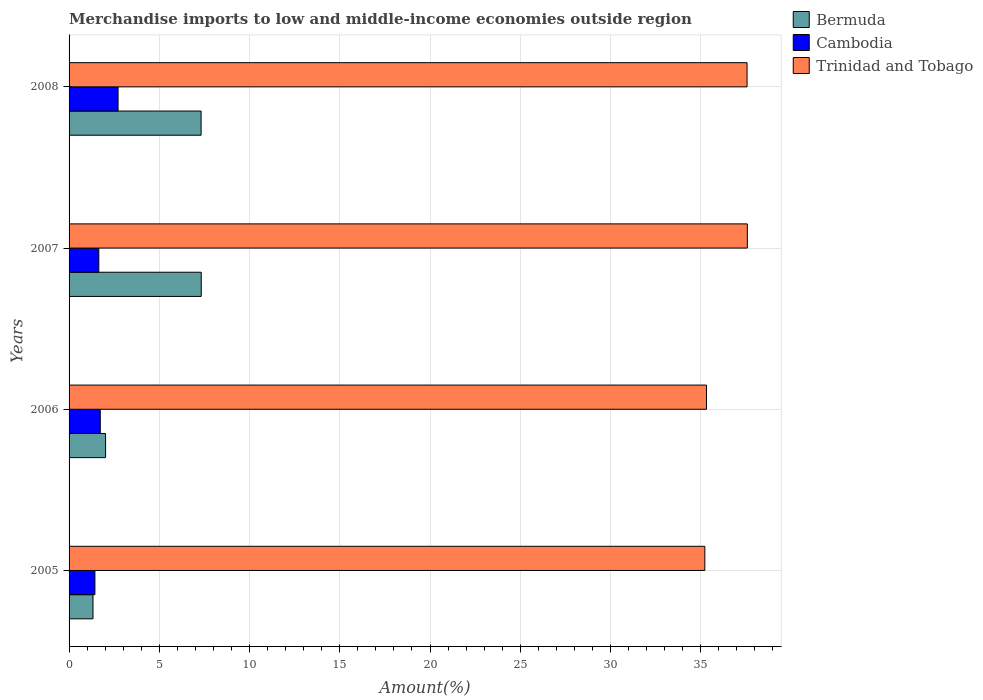How many different coloured bars are there?
Give a very brief answer. 3. Are the number of bars per tick equal to the number of legend labels?
Give a very brief answer. Yes. Are the number of bars on each tick of the Y-axis equal?
Your answer should be compact. Yes. What is the label of the 3rd group of bars from the top?
Keep it short and to the point. 2006. In how many cases, is the number of bars for a given year not equal to the number of legend labels?
Make the answer very short. 0. What is the percentage of amount earned from merchandise imports in Bermuda in 2007?
Your answer should be very brief. 7.32. Across all years, what is the maximum percentage of amount earned from merchandise imports in Bermuda?
Make the answer very short. 7.32. Across all years, what is the minimum percentage of amount earned from merchandise imports in Cambodia?
Offer a very short reply. 1.43. In which year was the percentage of amount earned from merchandise imports in Trinidad and Tobago maximum?
Give a very brief answer. 2007. What is the total percentage of amount earned from merchandise imports in Trinidad and Tobago in the graph?
Give a very brief answer. 145.7. What is the difference between the percentage of amount earned from merchandise imports in Bermuda in 2005 and that in 2007?
Give a very brief answer. -6. What is the difference between the percentage of amount earned from merchandise imports in Cambodia in 2006 and the percentage of amount earned from merchandise imports in Bermuda in 2005?
Offer a terse response. 0.4. What is the average percentage of amount earned from merchandise imports in Cambodia per year?
Offer a very short reply. 1.88. In the year 2005, what is the difference between the percentage of amount earned from merchandise imports in Bermuda and percentage of amount earned from merchandise imports in Cambodia?
Make the answer very short. -0.11. In how many years, is the percentage of amount earned from merchandise imports in Cambodia greater than 33 %?
Provide a succinct answer. 0. What is the ratio of the percentage of amount earned from merchandise imports in Bermuda in 2005 to that in 2008?
Give a very brief answer. 0.18. Is the percentage of amount earned from merchandise imports in Trinidad and Tobago in 2005 less than that in 2006?
Keep it short and to the point. Yes. What is the difference between the highest and the second highest percentage of amount earned from merchandise imports in Bermuda?
Ensure brevity in your answer.  0.01. What is the difference between the highest and the lowest percentage of amount earned from merchandise imports in Trinidad and Tobago?
Offer a terse response. 2.35. Is the sum of the percentage of amount earned from merchandise imports in Trinidad and Tobago in 2005 and 2006 greater than the maximum percentage of amount earned from merchandise imports in Bermuda across all years?
Make the answer very short. Yes. What does the 3rd bar from the top in 2007 represents?
Provide a short and direct response. Bermuda. What does the 2nd bar from the bottom in 2007 represents?
Your response must be concise. Cambodia. Is it the case that in every year, the sum of the percentage of amount earned from merchandise imports in Cambodia and percentage of amount earned from merchandise imports in Bermuda is greater than the percentage of amount earned from merchandise imports in Trinidad and Tobago?
Keep it short and to the point. No. How many bars are there?
Your response must be concise. 12. Are all the bars in the graph horizontal?
Provide a short and direct response. Yes. How many years are there in the graph?
Offer a terse response. 4. Are the values on the major ticks of X-axis written in scientific E-notation?
Your answer should be very brief. No. Does the graph contain grids?
Make the answer very short. Yes. What is the title of the graph?
Ensure brevity in your answer.  Merchandise imports to low and middle-income economies outside region. What is the label or title of the X-axis?
Your response must be concise. Amount(%). What is the label or title of the Y-axis?
Offer a very short reply. Years. What is the Amount(%) in Bermuda in 2005?
Keep it short and to the point. 1.33. What is the Amount(%) of Cambodia in 2005?
Offer a very short reply. 1.43. What is the Amount(%) of Trinidad and Tobago in 2005?
Your answer should be very brief. 35.23. What is the Amount(%) of Bermuda in 2006?
Provide a succinct answer. 2.02. What is the Amount(%) of Cambodia in 2006?
Offer a very short reply. 1.73. What is the Amount(%) in Trinidad and Tobago in 2006?
Ensure brevity in your answer.  35.32. What is the Amount(%) in Bermuda in 2007?
Keep it short and to the point. 7.32. What is the Amount(%) in Cambodia in 2007?
Keep it short and to the point. 1.65. What is the Amount(%) in Trinidad and Tobago in 2007?
Your response must be concise. 37.58. What is the Amount(%) of Bermuda in 2008?
Your answer should be compact. 7.32. What is the Amount(%) of Cambodia in 2008?
Make the answer very short. 2.71. What is the Amount(%) in Trinidad and Tobago in 2008?
Your answer should be very brief. 37.57. Across all years, what is the maximum Amount(%) in Bermuda?
Your answer should be very brief. 7.32. Across all years, what is the maximum Amount(%) in Cambodia?
Offer a very short reply. 2.71. Across all years, what is the maximum Amount(%) in Trinidad and Tobago?
Your answer should be very brief. 37.58. Across all years, what is the minimum Amount(%) of Bermuda?
Ensure brevity in your answer.  1.33. Across all years, what is the minimum Amount(%) in Cambodia?
Your answer should be compact. 1.43. Across all years, what is the minimum Amount(%) of Trinidad and Tobago?
Your answer should be very brief. 35.23. What is the total Amount(%) of Bermuda in the graph?
Provide a short and direct response. 17.99. What is the total Amount(%) of Cambodia in the graph?
Your answer should be compact. 7.52. What is the total Amount(%) of Trinidad and Tobago in the graph?
Ensure brevity in your answer.  145.7. What is the difference between the Amount(%) of Bermuda in 2005 and that in 2006?
Offer a terse response. -0.7. What is the difference between the Amount(%) in Cambodia in 2005 and that in 2006?
Your response must be concise. -0.3. What is the difference between the Amount(%) of Trinidad and Tobago in 2005 and that in 2006?
Provide a succinct answer. -0.09. What is the difference between the Amount(%) of Bermuda in 2005 and that in 2007?
Your response must be concise. -6. What is the difference between the Amount(%) in Cambodia in 2005 and that in 2007?
Ensure brevity in your answer.  -0.22. What is the difference between the Amount(%) in Trinidad and Tobago in 2005 and that in 2007?
Make the answer very short. -2.35. What is the difference between the Amount(%) of Bermuda in 2005 and that in 2008?
Your answer should be compact. -5.99. What is the difference between the Amount(%) of Cambodia in 2005 and that in 2008?
Provide a succinct answer. -1.28. What is the difference between the Amount(%) in Trinidad and Tobago in 2005 and that in 2008?
Give a very brief answer. -2.34. What is the difference between the Amount(%) of Bermuda in 2006 and that in 2007?
Offer a terse response. -5.3. What is the difference between the Amount(%) of Cambodia in 2006 and that in 2007?
Your answer should be compact. 0.08. What is the difference between the Amount(%) of Trinidad and Tobago in 2006 and that in 2007?
Ensure brevity in your answer.  -2.26. What is the difference between the Amount(%) of Bermuda in 2006 and that in 2008?
Keep it short and to the point. -5.29. What is the difference between the Amount(%) in Cambodia in 2006 and that in 2008?
Provide a succinct answer. -0.99. What is the difference between the Amount(%) in Trinidad and Tobago in 2006 and that in 2008?
Your answer should be very brief. -2.25. What is the difference between the Amount(%) of Bermuda in 2007 and that in 2008?
Keep it short and to the point. 0.01. What is the difference between the Amount(%) in Cambodia in 2007 and that in 2008?
Ensure brevity in your answer.  -1.07. What is the difference between the Amount(%) in Trinidad and Tobago in 2007 and that in 2008?
Keep it short and to the point. 0.01. What is the difference between the Amount(%) in Bermuda in 2005 and the Amount(%) in Cambodia in 2006?
Your answer should be very brief. -0.4. What is the difference between the Amount(%) in Bermuda in 2005 and the Amount(%) in Trinidad and Tobago in 2006?
Provide a succinct answer. -33.99. What is the difference between the Amount(%) of Cambodia in 2005 and the Amount(%) of Trinidad and Tobago in 2006?
Offer a very short reply. -33.89. What is the difference between the Amount(%) in Bermuda in 2005 and the Amount(%) in Cambodia in 2007?
Ensure brevity in your answer.  -0.32. What is the difference between the Amount(%) of Bermuda in 2005 and the Amount(%) of Trinidad and Tobago in 2007?
Provide a short and direct response. -36.26. What is the difference between the Amount(%) of Cambodia in 2005 and the Amount(%) of Trinidad and Tobago in 2007?
Keep it short and to the point. -36.15. What is the difference between the Amount(%) in Bermuda in 2005 and the Amount(%) in Cambodia in 2008?
Your response must be concise. -1.39. What is the difference between the Amount(%) of Bermuda in 2005 and the Amount(%) of Trinidad and Tobago in 2008?
Your answer should be compact. -36.24. What is the difference between the Amount(%) in Cambodia in 2005 and the Amount(%) in Trinidad and Tobago in 2008?
Your answer should be very brief. -36.14. What is the difference between the Amount(%) of Bermuda in 2006 and the Amount(%) of Cambodia in 2007?
Offer a terse response. 0.37. What is the difference between the Amount(%) in Bermuda in 2006 and the Amount(%) in Trinidad and Tobago in 2007?
Offer a terse response. -35.56. What is the difference between the Amount(%) in Cambodia in 2006 and the Amount(%) in Trinidad and Tobago in 2007?
Your response must be concise. -35.85. What is the difference between the Amount(%) in Bermuda in 2006 and the Amount(%) in Cambodia in 2008?
Offer a terse response. -0.69. What is the difference between the Amount(%) in Bermuda in 2006 and the Amount(%) in Trinidad and Tobago in 2008?
Ensure brevity in your answer.  -35.55. What is the difference between the Amount(%) in Cambodia in 2006 and the Amount(%) in Trinidad and Tobago in 2008?
Give a very brief answer. -35.84. What is the difference between the Amount(%) of Bermuda in 2007 and the Amount(%) of Cambodia in 2008?
Offer a terse response. 4.61. What is the difference between the Amount(%) of Bermuda in 2007 and the Amount(%) of Trinidad and Tobago in 2008?
Offer a very short reply. -30.24. What is the difference between the Amount(%) in Cambodia in 2007 and the Amount(%) in Trinidad and Tobago in 2008?
Provide a succinct answer. -35.92. What is the average Amount(%) in Bermuda per year?
Your response must be concise. 4.5. What is the average Amount(%) of Cambodia per year?
Provide a short and direct response. 1.88. What is the average Amount(%) in Trinidad and Tobago per year?
Give a very brief answer. 36.42. In the year 2005, what is the difference between the Amount(%) of Bermuda and Amount(%) of Cambodia?
Provide a short and direct response. -0.11. In the year 2005, what is the difference between the Amount(%) of Bermuda and Amount(%) of Trinidad and Tobago?
Give a very brief answer. -33.9. In the year 2005, what is the difference between the Amount(%) of Cambodia and Amount(%) of Trinidad and Tobago?
Your response must be concise. -33.8. In the year 2006, what is the difference between the Amount(%) of Bermuda and Amount(%) of Cambodia?
Provide a short and direct response. 0.29. In the year 2006, what is the difference between the Amount(%) in Bermuda and Amount(%) in Trinidad and Tobago?
Your response must be concise. -33.3. In the year 2006, what is the difference between the Amount(%) of Cambodia and Amount(%) of Trinidad and Tobago?
Ensure brevity in your answer.  -33.59. In the year 2007, what is the difference between the Amount(%) of Bermuda and Amount(%) of Cambodia?
Provide a succinct answer. 5.68. In the year 2007, what is the difference between the Amount(%) of Bermuda and Amount(%) of Trinidad and Tobago?
Make the answer very short. -30.26. In the year 2007, what is the difference between the Amount(%) in Cambodia and Amount(%) in Trinidad and Tobago?
Your response must be concise. -35.94. In the year 2008, what is the difference between the Amount(%) of Bermuda and Amount(%) of Cambodia?
Ensure brevity in your answer.  4.6. In the year 2008, what is the difference between the Amount(%) of Bermuda and Amount(%) of Trinidad and Tobago?
Provide a succinct answer. -30.25. In the year 2008, what is the difference between the Amount(%) of Cambodia and Amount(%) of Trinidad and Tobago?
Give a very brief answer. -34.85. What is the ratio of the Amount(%) of Bermuda in 2005 to that in 2006?
Provide a succinct answer. 0.66. What is the ratio of the Amount(%) in Cambodia in 2005 to that in 2006?
Ensure brevity in your answer.  0.83. What is the ratio of the Amount(%) of Trinidad and Tobago in 2005 to that in 2006?
Provide a short and direct response. 1. What is the ratio of the Amount(%) of Bermuda in 2005 to that in 2007?
Your answer should be compact. 0.18. What is the ratio of the Amount(%) of Cambodia in 2005 to that in 2007?
Provide a short and direct response. 0.87. What is the ratio of the Amount(%) of Trinidad and Tobago in 2005 to that in 2007?
Provide a short and direct response. 0.94. What is the ratio of the Amount(%) in Bermuda in 2005 to that in 2008?
Make the answer very short. 0.18. What is the ratio of the Amount(%) in Cambodia in 2005 to that in 2008?
Keep it short and to the point. 0.53. What is the ratio of the Amount(%) of Trinidad and Tobago in 2005 to that in 2008?
Give a very brief answer. 0.94. What is the ratio of the Amount(%) in Bermuda in 2006 to that in 2007?
Provide a short and direct response. 0.28. What is the ratio of the Amount(%) of Cambodia in 2006 to that in 2007?
Give a very brief answer. 1.05. What is the ratio of the Amount(%) of Trinidad and Tobago in 2006 to that in 2007?
Your answer should be compact. 0.94. What is the ratio of the Amount(%) of Bermuda in 2006 to that in 2008?
Keep it short and to the point. 0.28. What is the ratio of the Amount(%) in Cambodia in 2006 to that in 2008?
Keep it short and to the point. 0.64. What is the ratio of the Amount(%) of Trinidad and Tobago in 2006 to that in 2008?
Your response must be concise. 0.94. What is the ratio of the Amount(%) of Cambodia in 2007 to that in 2008?
Offer a very short reply. 0.61. What is the difference between the highest and the second highest Amount(%) in Bermuda?
Your answer should be compact. 0.01. What is the difference between the highest and the second highest Amount(%) in Cambodia?
Your answer should be compact. 0.99. What is the difference between the highest and the second highest Amount(%) in Trinidad and Tobago?
Your answer should be very brief. 0.01. What is the difference between the highest and the lowest Amount(%) of Bermuda?
Offer a very short reply. 6. What is the difference between the highest and the lowest Amount(%) in Cambodia?
Provide a short and direct response. 1.28. What is the difference between the highest and the lowest Amount(%) of Trinidad and Tobago?
Offer a very short reply. 2.35. 